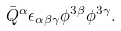<formula> <loc_0><loc_0><loc_500><loc_500>\bar { Q } ^ { \alpha } \epsilon _ { \alpha \beta \gamma } \phi ^ { 3 \beta } \phi ^ { 3 \gamma } .</formula> 